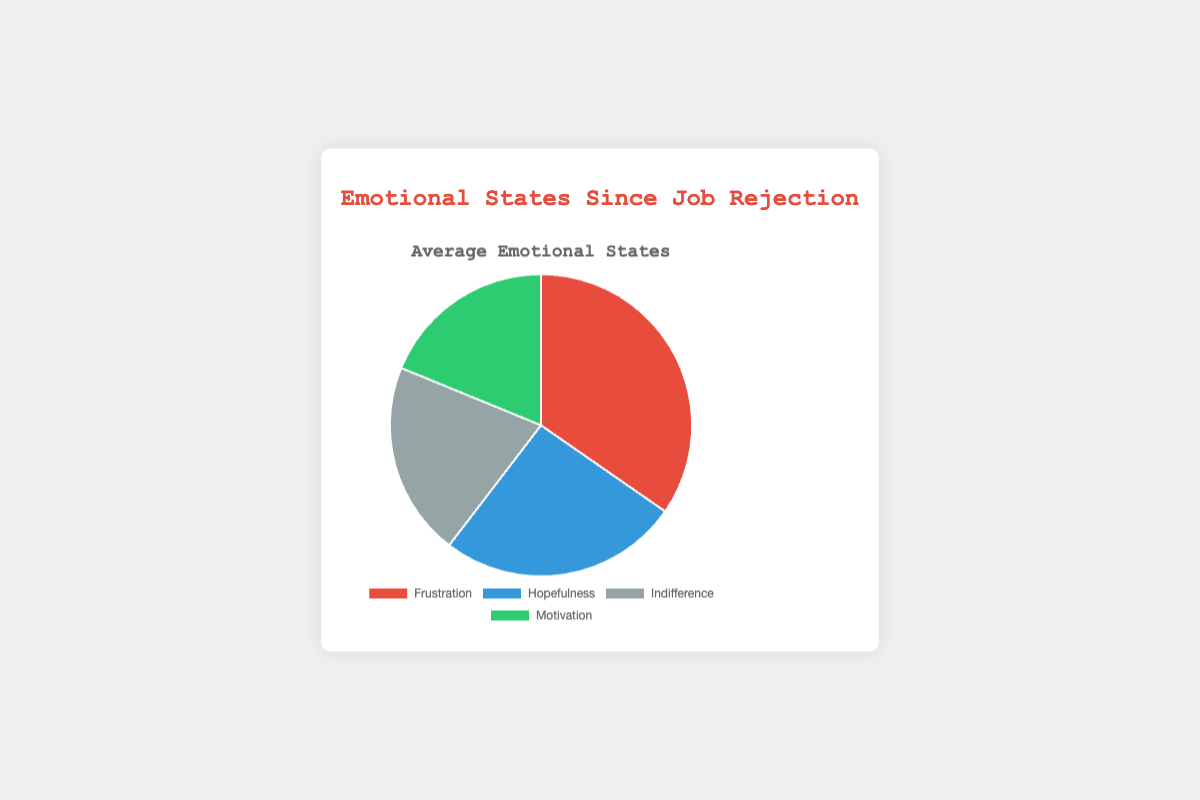What is the most dominant emotional state since the job rejection in the pie chart? The dominant emotional state can be determined by identifying the segment that takes up the largest portion of the pie chart. The largest segment in the pie chart is the one labeled 'Frustration'.
Answer: Frustration Which emotional state has the smallest percentage? To find the smallest percentage, examine the pie chart and identify the segment that takes up the smallest portion. 'Motivation' and 'Indifference' share an equal and smaller portion compared to the others.
Answer: Motivation and Indifference What is the combined percentage of 'Hopefulness' and 'Motivation'? To find the combined percentage, add the percentages of 'Hopefulness' and 'Motivation'. From the pie chart, 'Hopefulness' is 25% and 'Motivation' is 20%. So, the combined percentage is 25% + 20% = 45%.
Answer: 45% How does 'Indifference' compare to 'Frustration' in terms of percentage? To compare, look at the data representation of both emotional states. 'Frustration' has a larger portion compared to 'Indifference'.
Answer: Frustration is greater What is the average percentage for each emotional state illustrated in the pie chart? Calculate the average by dividing the total percentage (which is 100%) by the number of emotional states (4). 100% / 4 = 25%. Then, verify by referencing the chart. Average percentages approximately match: Frustration (35%), Hopefulness (25%), Indifference (20%), Motivation (20%).
Answer: Frustration: 35%, Hopefulness: 25%, Indifference: 20%, Motivation: 20% If you combine the percentages of 'Indifference' and 'Hopefulness', does it exceed 'Frustration'? Add the percentages for 'Indifference' and 'Hopefulness'. 'Indifference' (20%) + 'Hopefulness' (25%) = 45%, which is greater than 'Frustration' (35%).
Answer: Yes Which color represents 'Hopefulness' and what is its significance in the appearance of the chart? 'Hopefulness' is represented by the blue segment. It visually indicates the portion of hopefulness within the overall emotional state distribution since job rejection.
Answer: Blue How much less is 'Motivation' compared to 'Frustration' in percentage? Subtract the percentage of 'Motivation' from 'Frustration'. 'Frustration' is 35% and 'Motivation' is 20%. Thus, 35% - 20% = 15%.
Answer: 15% less How does the segment for 'Indifference' compare visually with 'Hopefulness'? Visually inspect the pie chart to compare the sizes of the segments. 'Indifference' appears smaller than 'Hopefulness', indicating it has a lesser percentage in the distribution.
Answer: Indifference is smaller What is the total percentage of emotional states expressed but excluding 'Frustration'? Subtract the percentage of 'Frustration' from the total 100%. 'Frustration' is 35%, and the remaining total is 100% - 35% = 65%.
Answer: 65% 